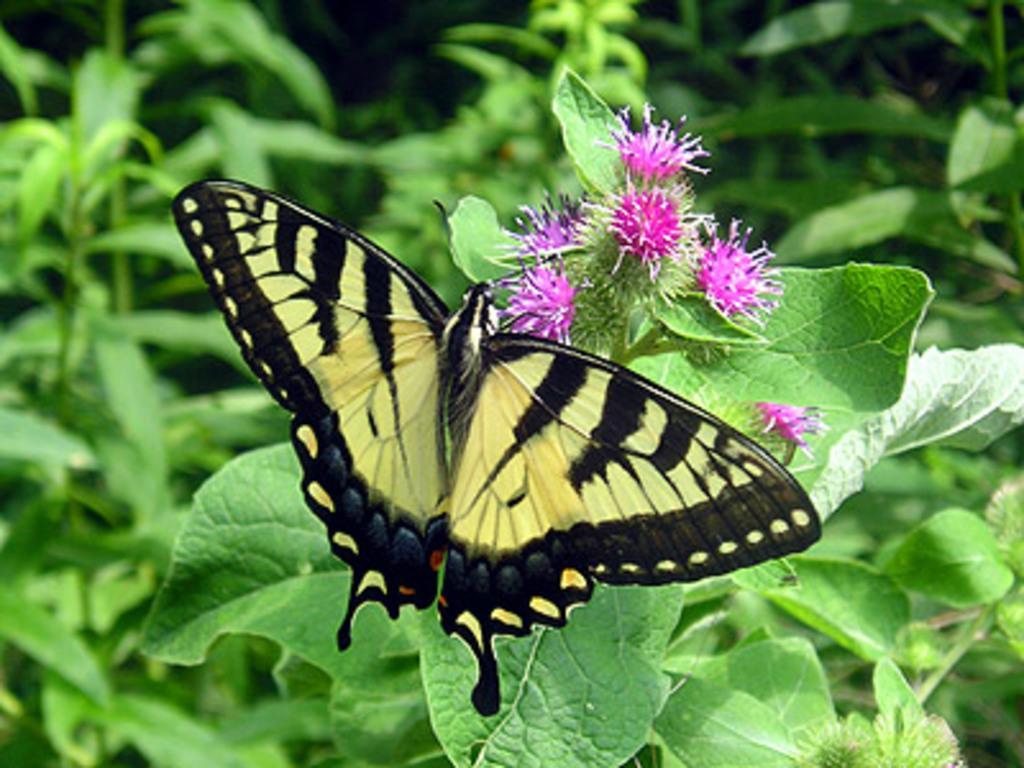Could you give a brief overview of what you see in this image? As we can see in the image there are plants, flowers and butterfly. 